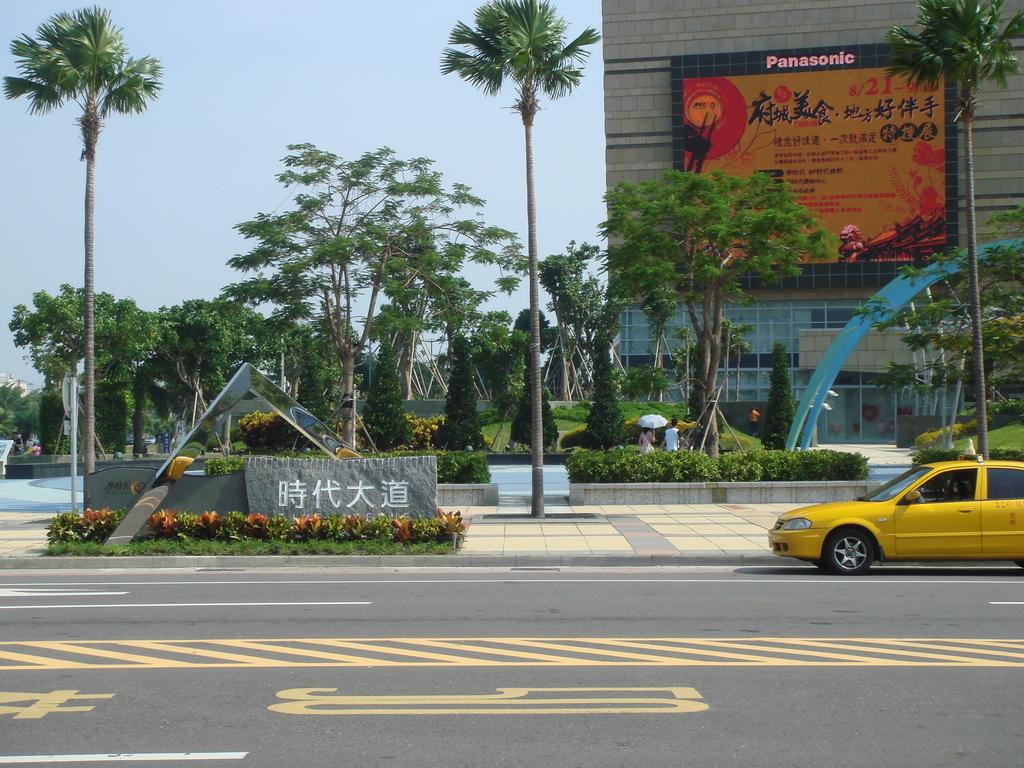What company made the sign on the building?
Give a very brief answer. Panasonic. 